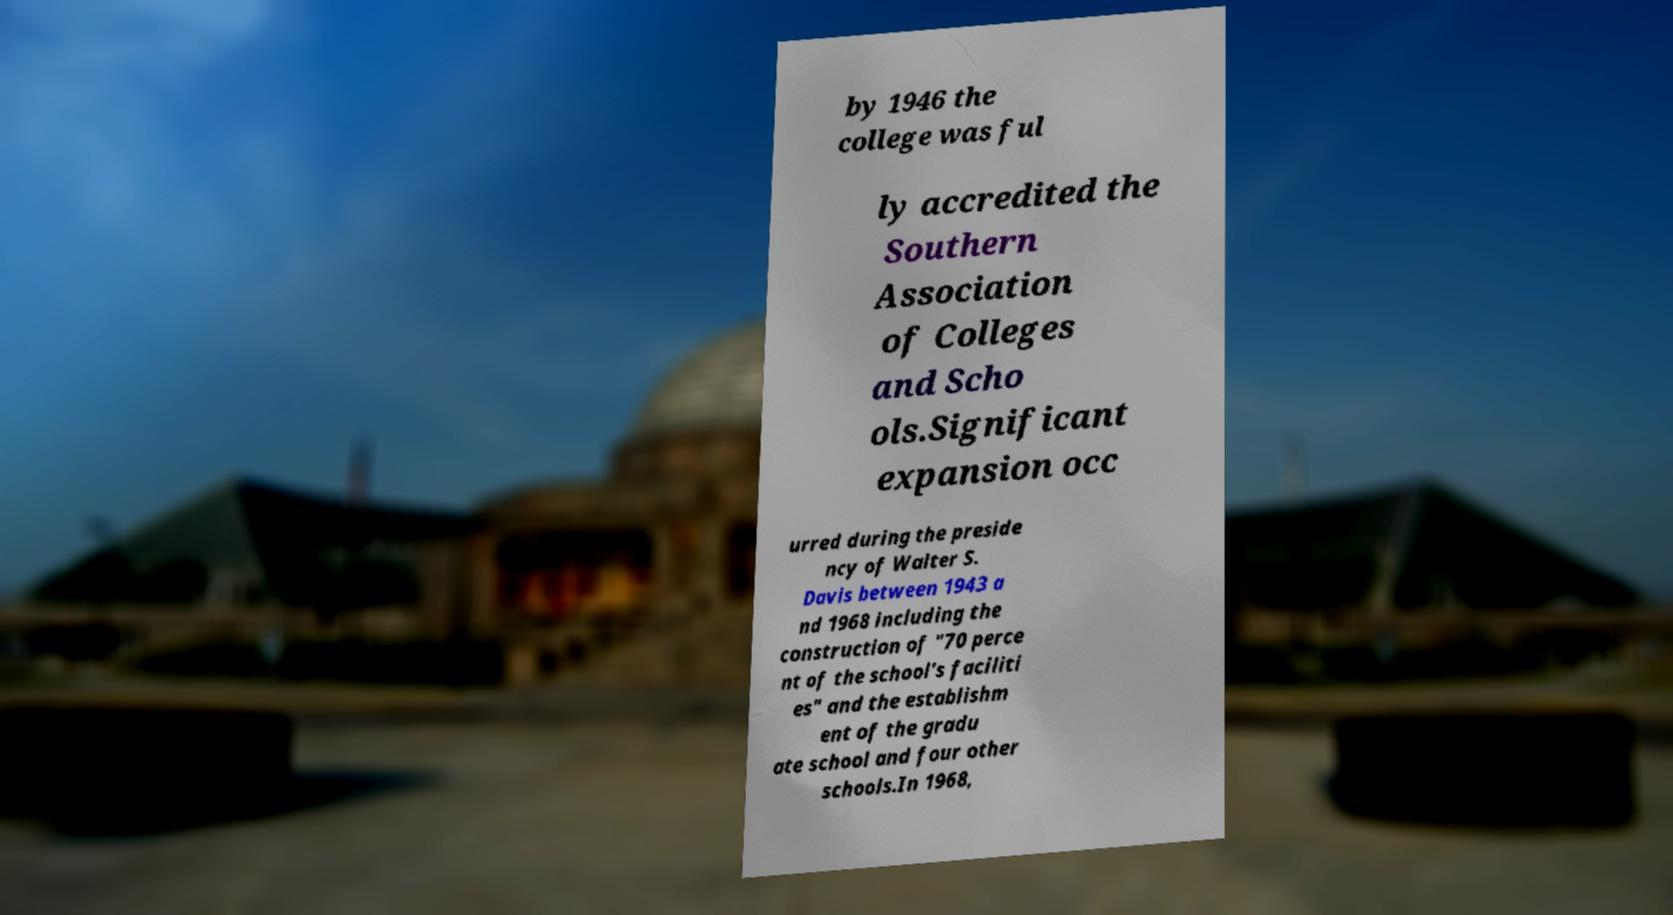For documentation purposes, I need the text within this image transcribed. Could you provide that? by 1946 the college was ful ly accredited the Southern Association of Colleges and Scho ols.Significant expansion occ urred during the preside ncy of Walter S. Davis between 1943 a nd 1968 including the construction of "70 perce nt of the school's faciliti es" and the establishm ent of the gradu ate school and four other schools.In 1968, 